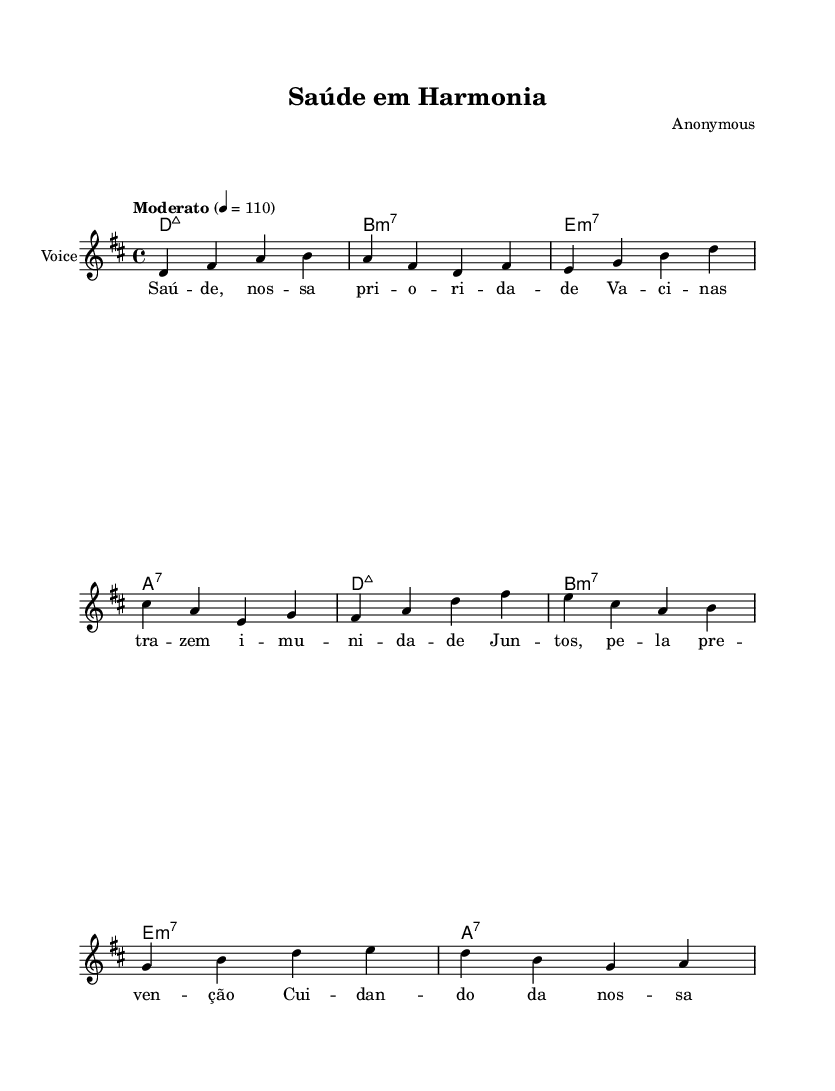What is the key signature of this music? The key signature is marked as D major, which contains two sharps (F# and C#). This is determined by looking at the key signature at the beginning of the piece.
Answer: D major What is the time signature of this music? The time signature is 4/4, which indicates there are four beats in each measure and the quarter note gets one beat. This is identified at the start of the score.
Answer: 4/4 What is the tempo marking for this piece? The tempo marking is "Moderato," which suggests a moderate speed of around 110 beats per minute. This is specified at the beginning of the score as a directive.
Answer: Moderato How many measures are in the melody section? The melody section contains eight measures. This can be counted directly from the measure lines shown in the sheet music notation.
Answer: Eight What chords are used in the first two measures? The chords used in the first two measures are D major 7 and B minor 7. This is determined by analyzing the chord symbols above the melody for those specific measures.
Answer: D major 7, B minor 7 What theme is reflected in the lyrics of the piece? The theme reflected in the lyrics is community wellness and vaccination. This is inferred by examining the lyrics, which speak about health, vaccines, and prevention efforts.
Answer: Community wellness, vaccination Which instrument is indicated for the score? The instrument indicated for the score is "Voice," as marked in the staff notation. This can be seen in the instrument name written at the start of the staff.
Answer: Voice 